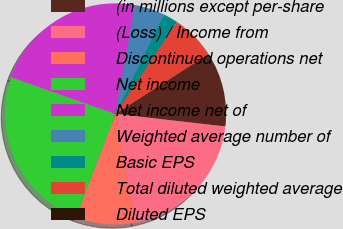<chart> <loc_0><loc_0><loc_500><loc_500><pie_chart><fcel>(in millions except per-share<fcel>(Loss) / Income from<fcel>Discontinued operations net<fcel>Net income<fcel>Net income net of<fcel>Weighted average number of<fcel>Basic EPS<fcel>Total diluted weighted average<fcel>Diluted EPS<nl><fcel>10.86%<fcel>20.28%<fcel>8.69%<fcel>24.62%<fcel>22.45%<fcel>4.36%<fcel>2.19%<fcel>6.52%<fcel>0.03%<nl></chart> 